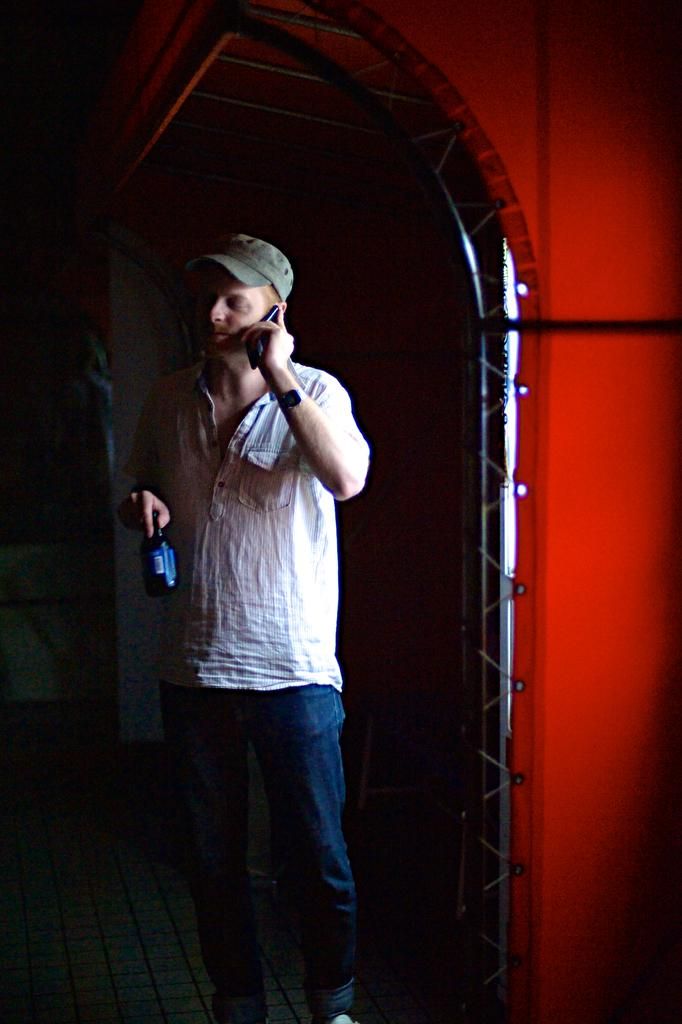Who or what is the main subject in the image? There is a person in the image. What is the person holding in their hands? The person is holding a bottle and a phone. What can be seen in the background of the image? There is a tent in the background of the image. What rule is the mom enforcing in the image? There is no mention of a mom or any rules in the image. 